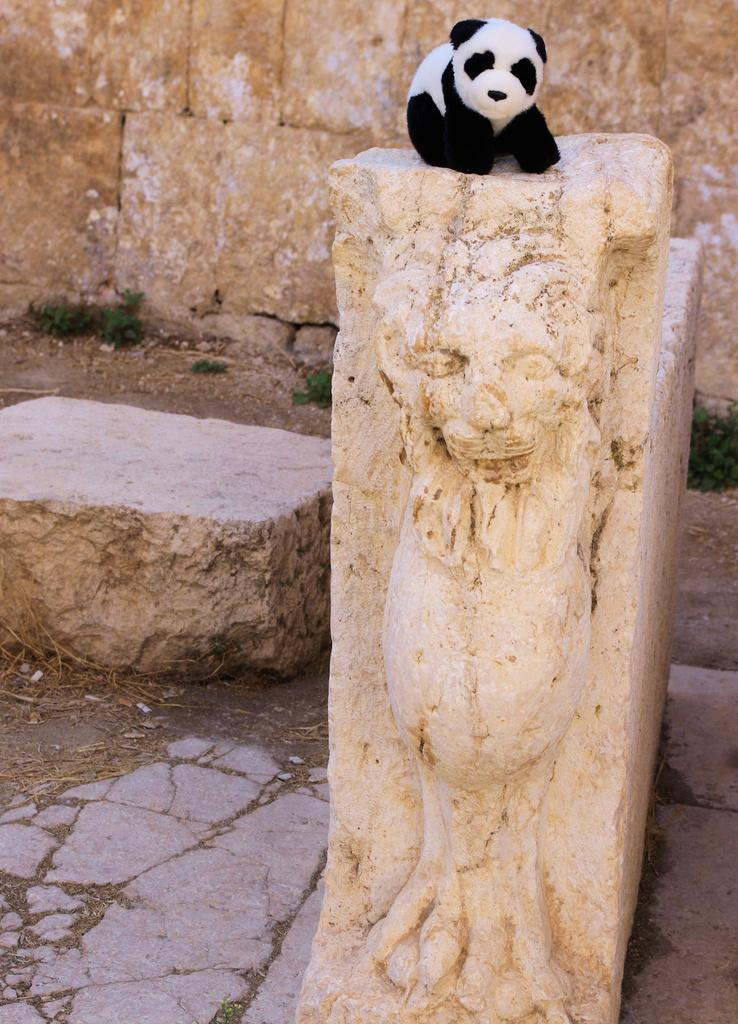What is located in the center of the image? There are stones and a sculpture in the center of the image. What is placed on the stones? There is a doll on the stones. What is the color scheme of the doll? The doll is in black and white color. What can be seen in the background of the image? There is a wall and grass in the background of the image. How many cattle are grazing in the background of the image? There are no cattle present in the image; it features a wall and grass in the background. What type of juice can be seen in the image? There is no juice present in the image. 